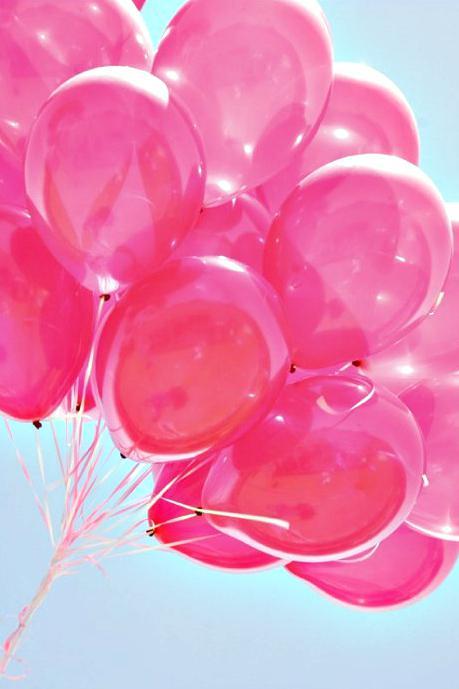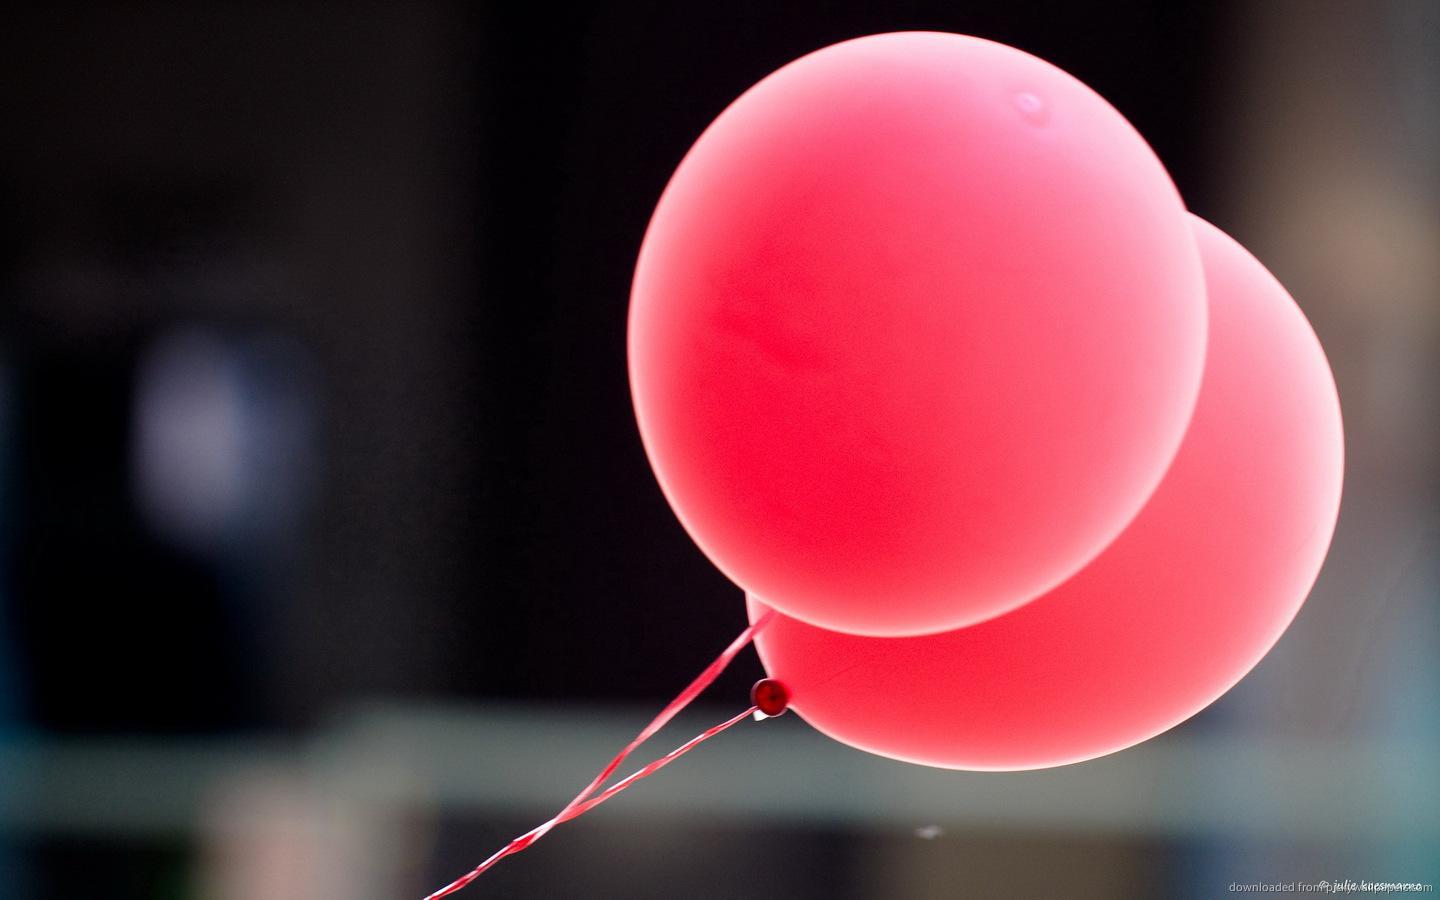The first image is the image on the left, the second image is the image on the right. Considering the images on both sides, is "In one of the images a seated child is near many balloons." valid? Answer yes or no. No. The first image is the image on the left, the second image is the image on the right. For the images shown, is this caption "There is a group of pink balloons together with trees in the background in the right image." true? Answer yes or no. No. 